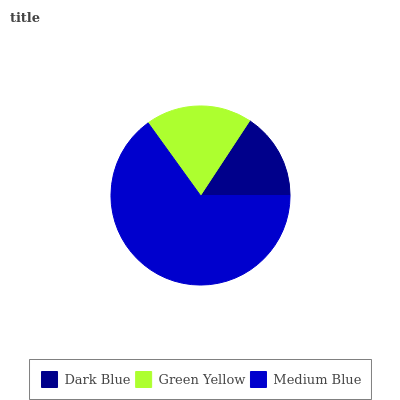Is Dark Blue the minimum?
Answer yes or no. Yes. Is Medium Blue the maximum?
Answer yes or no. Yes. Is Green Yellow the minimum?
Answer yes or no. No. Is Green Yellow the maximum?
Answer yes or no. No. Is Green Yellow greater than Dark Blue?
Answer yes or no. Yes. Is Dark Blue less than Green Yellow?
Answer yes or no. Yes. Is Dark Blue greater than Green Yellow?
Answer yes or no. No. Is Green Yellow less than Dark Blue?
Answer yes or no. No. Is Green Yellow the high median?
Answer yes or no. Yes. Is Green Yellow the low median?
Answer yes or no. Yes. Is Dark Blue the high median?
Answer yes or no. No. Is Dark Blue the low median?
Answer yes or no. No. 